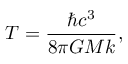<formula> <loc_0><loc_0><loc_500><loc_500>T = { \frac { \hbar { c } ^ { 3 } } { 8 \pi G M k } } ,</formula> 